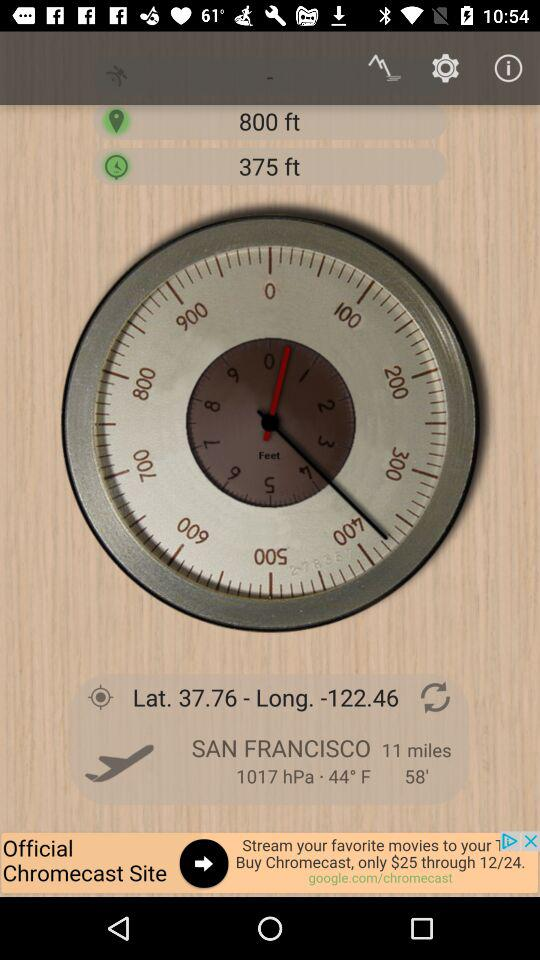What is the latitude? The latitude is 37.76. 